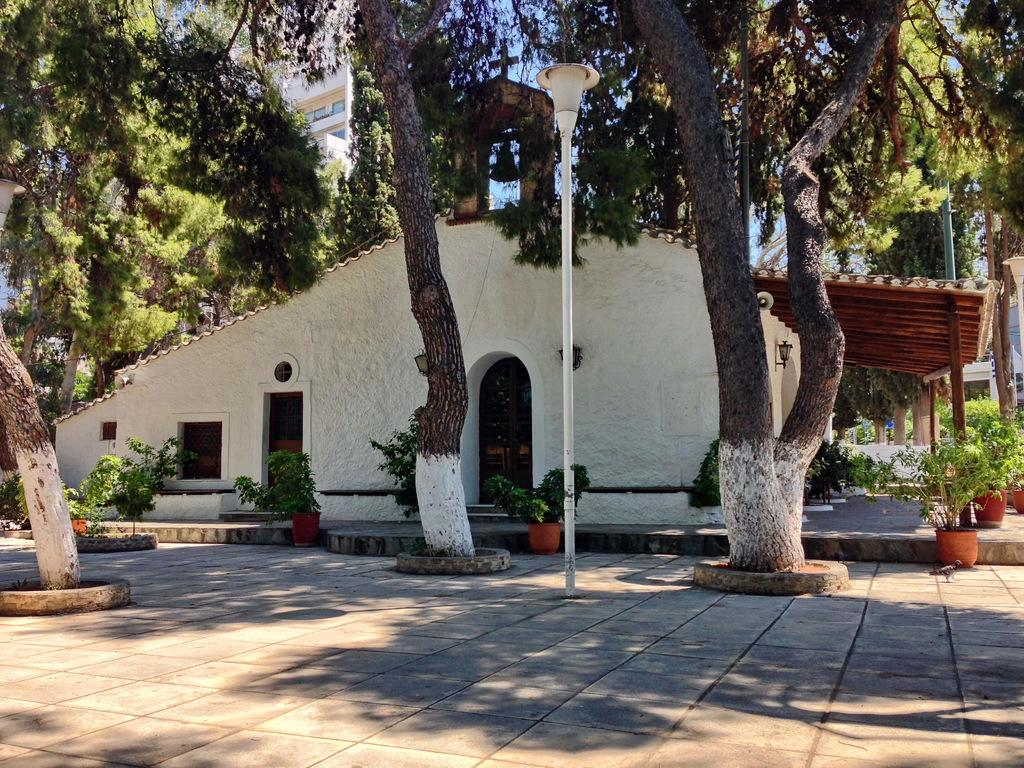What type of structure is present in the image? There is a house in the image. What color is the house? The house is white. What is visible at the bottom of the image? There is a ground at the bottom of the image. What can be seen in the background of the image? There are many trees in the background of the image. What type of vegetation is present to the right of the image? There are plants to the right of the image. What type of account is being discussed in the image? There is no account being discussed in the image; it features a white house with trees and plants in the background. 